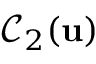<formula> <loc_0><loc_0><loc_500><loc_500>\mathcal { C } _ { 2 } ( u )</formula> 